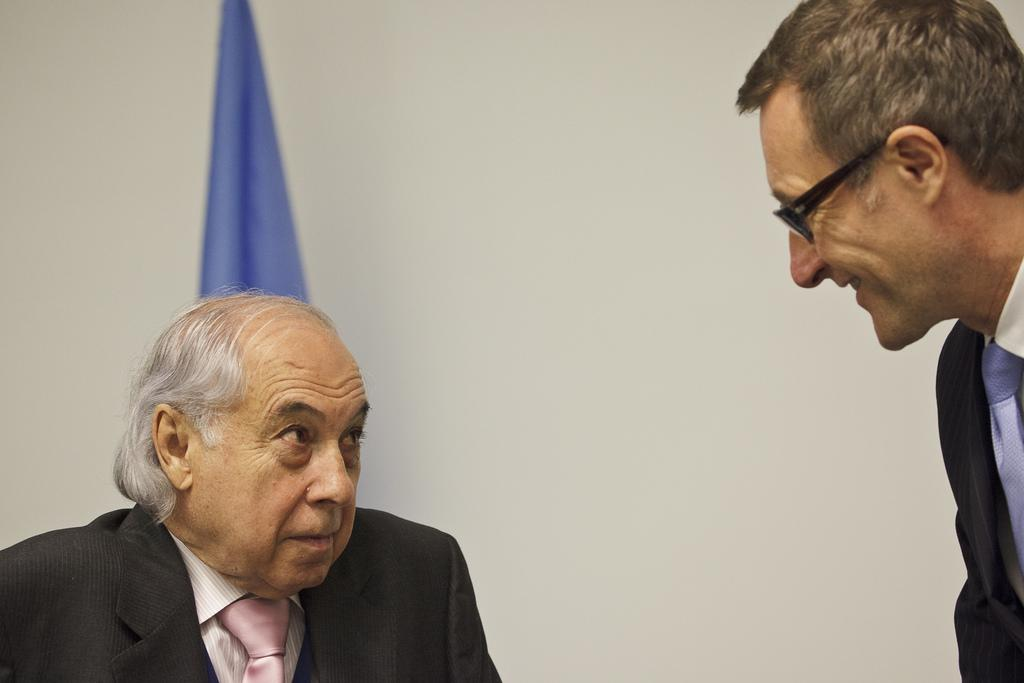How many people are present in the image? There are two men in the image. What can be seen in the background of the image? There is a wall and a blue cloth in the background of the image. What reason does the man on the left have for wearing a suit in the image? There is no indication in the image of the man's reason for wearing a suit, as the image does not show any suits being worn. 